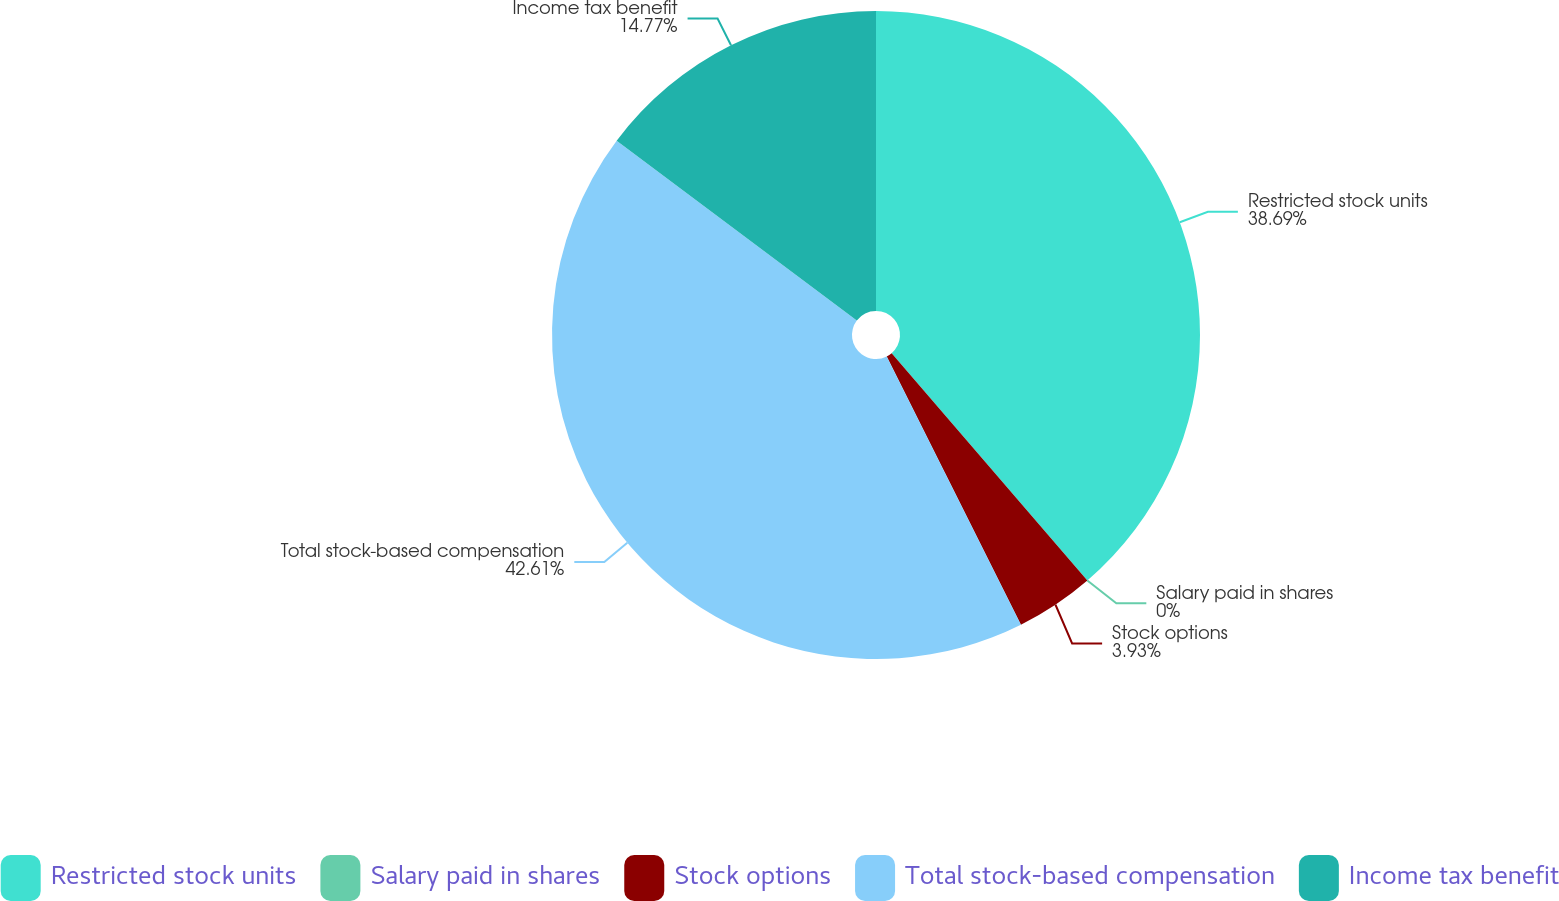<chart> <loc_0><loc_0><loc_500><loc_500><pie_chart><fcel>Restricted stock units<fcel>Salary paid in shares<fcel>Stock options<fcel>Total stock-based compensation<fcel>Income tax benefit<nl><fcel>38.69%<fcel>0.0%<fcel>3.93%<fcel>42.61%<fcel>14.77%<nl></chart> 